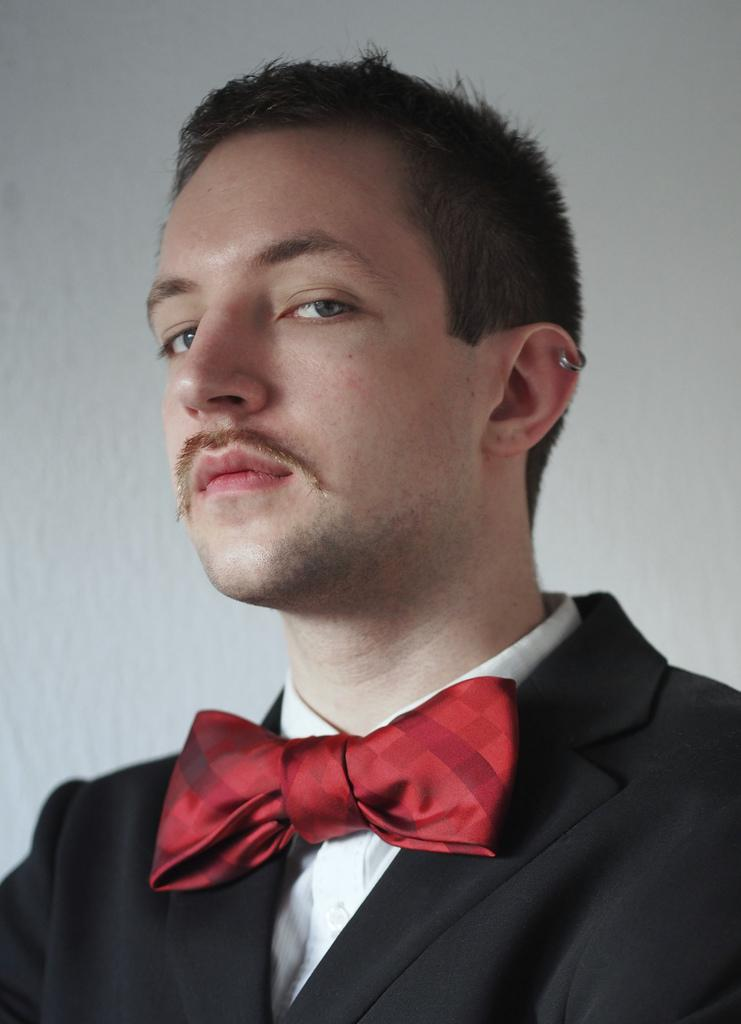Who or what is present in the image? There is a person in the image. What can be seen in the background of the image? There is a wall in the background of the image. What type of scarf is the person wearing in the image? There is no scarf visible in the image; the person is not wearing one. 